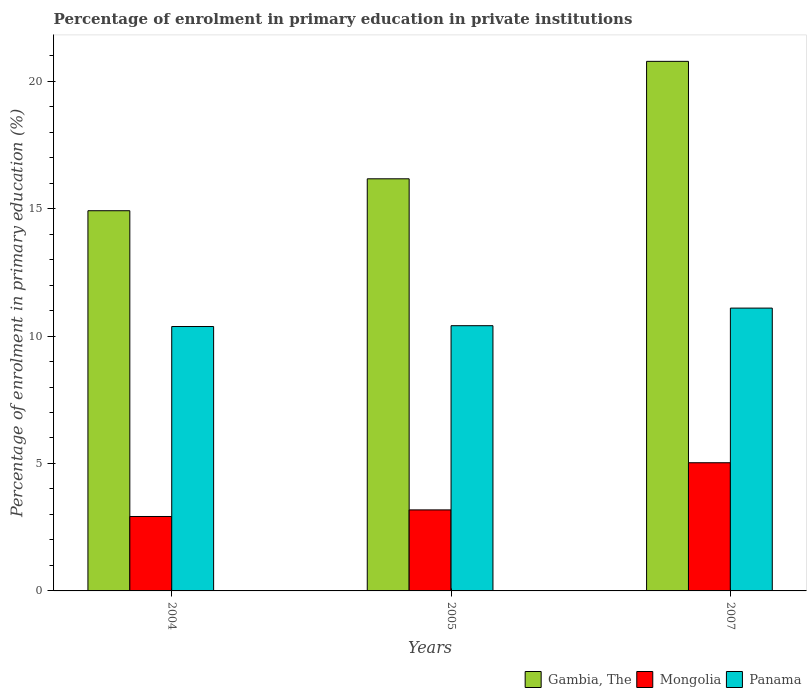How many different coloured bars are there?
Your response must be concise. 3. How many bars are there on the 3rd tick from the left?
Your answer should be very brief. 3. How many bars are there on the 3rd tick from the right?
Offer a terse response. 3. What is the label of the 2nd group of bars from the left?
Provide a succinct answer. 2005. In how many cases, is the number of bars for a given year not equal to the number of legend labels?
Your answer should be very brief. 0. What is the percentage of enrolment in primary education in Mongolia in 2005?
Give a very brief answer. 3.18. Across all years, what is the maximum percentage of enrolment in primary education in Mongolia?
Give a very brief answer. 5.03. Across all years, what is the minimum percentage of enrolment in primary education in Panama?
Provide a succinct answer. 10.37. In which year was the percentage of enrolment in primary education in Panama maximum?
Provide a short and direct response. 2007. In which year was the percentage of enrolment in primary education in Panama minimum?
Provide a short and direct response. 2004. What is the total percentage of enrolment in primary education in Panama in the graph?
Your response must be concise. 31.88. What is the difference between the percentage of enrolment in primary education in Gambia, The in 2005 and that in 2007?
Ensure brevity in your answer.  -4.61. What is the difference between the percentage of enrolment in primary education in Panama in 2005 and the percentage of enrolment in primary education in Gambia, The in 2004?
Make the answer very short. -4.51. What is the average percentage of enrolment in primary education in Panama per year?
Keep it short and to the point. 10.63. In the year 2005, what is the difference between the percentage of enrolment in primary education in Gambia, The and percentage of enrolment in primary education in Panama?
Provide a succinct answer. 5.76. What is the ratio of the percentage of enrolment in primary education in Gambia, The in 2004 to that in 2005?
Your answer should be very brief. 0.92. Is the percentage of enrolment in primary education in Gambia, The in 2004 less than that in 2007?
Ensure brevity in your answer.  Yes. What is the difference between the highest and the second highest percentage of enrolment in primary education in Gambia, The?
Provide a succinct answer. 4.61. What is the difference between the highest and the lowest percentage of enrolment in primary education in Panama?
Your answer should be compact. 0.72. What does the 2nd bar from the left in 2004 represents?
Keep it short and to the point. Mongolia. What does the 2nd bar from the right in 2005 represents?
Give a very brief answer. Mongolia. Is it the case that in every year, the sum of the percentage of enrolment in primary education in Gambia, The and percentage of enrolment in primary education in Mongolia is greater than the percentage of enrolment in primary education in Panama?
Provide a short and direct response. Yes. How many bars are there?
Offer a very short reply. 9. How many years are there in the graph?
Offer a terse response. 3. Are the values on the major ticks of Y-axis written in scientific E-notation?
Your answer should be compact. No. Does the graph contain any zero values?
Your response must be concise. No. What is the title of the graph?
Your response must be concise. Percentage of enrolment in primary education in private institutions. What is the label or title of the X-axis?
Ensure brevity in your answer.  Years. What is the label or title of the Y-axis?
Keep it short and to the point. Percentage of enrolment in primary education (%). What is the Percentage of enrolment in primary education (%) in Gambia, The in 2004?
Your answer should be compact. 14.92. What is the Percentage of enrolment in primary education (%) of Mongolia in 2004?
Keep it short and to the point. 2.92. What is the Percentage of enrolment in primary education (%) in Panama in 2004?
Provide a short and direct response. 10.37. What is the Percentage of enrolment in primary education (%) of Gambia, The in 2005?
Give a very brief answer. 16.17. What is the Percentage of enrolment in primary education (%) of Mongolia in 2005?
Provide a succinct answer. 3.18. What is the Percentage of enrolment in primary education (%) in Panama in 2005?
Provide a succinct answer. 10.41. What is the Percentage of enrolment in primary education (%) of Gambia, The in 2007?
Give a very brief answer. 20.78. What is the Percentage of enrolment in primary education (%) in Mongolia in 2007?
Provide a short and direct response. 5.03. What is the Percentage of enrolment in primary education (%) of Panama in 2007?
Your response must be concise. 11.1. Across all years, what is the maximum Percentage of enrolment in primary education (%) of Gambia, The?
Your answer should be very brief. 20.78. Across all years, what is the maximum Percentage of enrolment in primary education (%) in Mongolia?
Provide a succinct answer. 5.03. Across all years, what is the maximum Percentage of enrolment in primary education (%) in Panama?
Keep it short and to the point. 11.1. Across all years, what is the minimum Percentage of enrolment in primary education (%) in Gambia, The?
Keep it short and to the point. 14.92. Across all years, what is the minimum Percentage of enrolment in primary education (%) of Mongolia?
Provide a succinct answer. 2.92. Across all years, what is the minimum Percentage of enrolment in primary education (%) of Panama?
Offer a terse response. 10.37. What is the total Percentage of enrolment in primary education (%) of Gambia, The in the graph?
Your answer should be compact. 51.86. What is the total Percentage of enrolment in primary education (%) in Mongolia in the graph?
Offer a very short reply. 11.13. What is the total Percentage of enrolment in primary education (%) in Panama in the graph?
Provide a succinct answer. 31.88. What is the difference between the Percentage of enrolment in primary education (%) of Gambia, The in 2004 and that in 2005?
Provide a succinct answer. -1.25. What is the difference between the Percentage of enrolment in primary education (%) in Mongolia in 2004 and that in 2005?
Offer a very short reply. -0.26. What is the difference between the Percentage of enrolment in primary education (%) in Panama in 2004 and that in 2005?
Your answer should be compact. -0.03. What is the difference between the Percentage of enrolment in primary education (%) of Gambia, The in 2004 and that in 2007?
Offer a very short reply. -5.86. What is the difference between the Percentage of enrolment in primary education (%) in Mongolia in 2004 and that in 2007?
Give a very brief answer. -2.11. What is the difference between the Percentage of enrolment in primary education (%) of Panama in 2004 and that in 2007?
Provide a short and direct response. -0.72. What is the difference between the Percentage of enrolment in primary education (%) of Gambia, The in 2005 and that in 2007?
Offer a very short reply. -4.61. What is the difference between the Percentage of enrolment in primary education (%) in Mongolia in 2005 and that in 2007?
Offer a terse response. -1.85. What is the difference between the Percentage of enrolment in primary education (%) in Panama in 2005 and that in 2007?
Your answer should be very brief. -0.69. What is the difference between the Percentage of enrolment in primary education (%) in Gambia, The in 2004 and the Percentage of enrolment in primary education (%) in Mongolia in 2005?
Ensure brevity in your answer.  11.74. What is the difference between the Percentage of enrolment in primary education (%) of Gambia, The in 2004 and the Percentage of enrolment in primary education (%) of Panama in 2005?
Ensure brevity in your answer.  4.51. What is the difference between the Percentage of enrolment in primary education (%) in Mongolia in 2004 and the Percentage of enrolment in primary education (%) in Panama in 2005?
Your answer should be compact. -7.49. What is the difference between the Percentage of enrolment in primary education (%) in Gambia, The in 2004 and the Percentage of enrolment in primary education (%) in Mongolia in 2007?
Keep it short and to the point. 9.89. What is the difference between the Percentage of enrolment in primary education (%) of Gambia, The in 2004 and the Percentage of enrolment in primary education (%) of Panama in 2007?
Ensure brevity in your answer.  3.82. What is the difference between the Percentage of enrolment in primary education (%) in Mongolia in 2004 and the Percentage of enrolment in primary education (%) in Panama in 2007?
Ensure brevity in your answer.  -8.18. What is the difference between the Percentage of enrolment in primary education (%) in Gambia, The in 2005 and the Percentage of enrolment in primary education (%) in Mongolia in 2007?
Provide a succinct answer. 11.14. What is the difference between the Percentage of enrolment in primary education (%) in Gambia, The in 2005 and the Percentage of enrolment in primary education (%) in Panama in 2007?
Keep it short and to the point. 5.07. What is the difference between the Percentage of enrolment in primary education (%) of Mongolia in 2005 and the Percentage of enrolment in primary education (%) of Panama in 2007?
Give a very brief answer. -7.92. What is the average Percentage of enrolment in primary education (%) of Gambia, The per year?
Provide a succinct answer. 17.29. What is the average Percentage of enrolment in primary education (%) in Mongolia per year?
Offer a terse response. 3.71. What is the average Percentage of enrolment in primary education (%) in Panama per year?
Keep it short and to the point. 10.63. In the year 2004, what is the difference between the Percentage of enrolment in primary education (%) in Gambia, The and Percentage of enrolment in primary education (%) in Mongolia?
Your answer should be compact. 12. In the year 2004, what is the difference between the Percentage of enrolment in primary education (%) in Gambia, The and Percentage of enrolment in primary education (%) in Panama?
Your response must be concise. 4.54. In the year 2004, what is the difference between the Percentage of enrolment in primary education (%) of Mongolia and Percentage of enrolment in primary education (%) of Panama?
Provide a short and direct response. -7.45. In the year 2005, what is the difference between the Percentage of enrolment in primary education (%) in Gambia, The and Percentage of enrolment in primary education (%) in Mongolia?
Your response must be concise. 12.99. In the year 2005, what is the difference between the Percentage of enrolment in primary education (%) in Gambia, The and Percentage of enrolment in primary education (%) in Panama?
Give a very brief answer. 5.76. In the year 2005, what is the difference between the Percentage of enrolment in primary education (%) in Mongolia and Percentage of enrolment in primary education (%) in Panama?
Offer a very short reply. -7.23. In the year 2007, what is the difference between the Percentage of enrolment in primary education (%) of Gambia, The and Percentage of enrolment in primary education (%) of Mongolia?
Offer a terse response. 15.75. In the year 2007, what is the difference between the Percentage of enrolment in primary education (%) in Gambia, The and Percentage of enrolment in primary education (%) in Panama?
Ensure brevity in your answer.  9.68. In the year 2007, what is the difference between the Percentage of enrolment in primary education (%) of Mongolia and Percentage of enrolment in primary education (%) of Panama?
Give a very brief answer. -6.07. What is the ratio of the Percentage of enrolment in primary education (%) of Gambia, The in 2004 to that in 2005?
Your answer should be very brief. 0.92. What is the ratio of the Percentage of enrolment in primary education (%) of Mongolia in 2004 to that in 2005?
Ensure brevity in your answer.  0.92. What is the ratio of the Percentage of enrolment in primary education (%) in Panama in 2004 to that in 2005?
Give a very brief answer. 1. What is the ratio of the Percentage of enrolment in primary education (%) in Gambia, The in 2004 to that in 2007?
Provide a short and direct response. 0.72. What is the ratio of the Percentage of enrolment in primary education (%) of Mongolia in 2004 to that in 2007?
Offer a very short reply. 0.58. What is the ratio of the Percentage of enrolment in primary education (%) of Panama in 2004 to that in 2007?
Keep it short and to the point. 0.93. What is the ratio of the Percentage of enrolment in primary education (%) in Gambia, The in 2005 to that in 2007?
Offer a very short reply. 0.78. What is the ratio of the Percentage of enrolment in primary education (%) in Mongolia in 2005 to that in 2007?
Ensure brevity in your answer.  0.63. What is the ratio of the Percentage of enrolment in primary education (%) in Panama in 2005 to that in 2007?
Offer a very short reply. 0.94. What is the difference between the highest and the second highest Percentage of enrolment in primary education (%) of Gambia, The?
Ensure brevity in your answer.  4.61. What is the difference between the highest and the second highest Percentage of enrolment in primary education (%) of Mongolia?
Provide a succinct answer. 1.85. What is the difference between the highest and the second highest Percentage of enrolment in primary education (%) of Panama?
Your answer should be compact. 0.69. What is the difference between the highest and the lowest Percentage of enrolment in primary education (%) in Gambia, The?
Offer a terse response. 5.86. What is the difference between the highest and the lowest Percentage of enrolment in primary education (%) in Mongolia?
Your answer should be compact. 2.11. What is the difference between the highest and the lowest Percentage of enrolment in primary education (%) of Panama?
Make the answer very short. 0.72. 